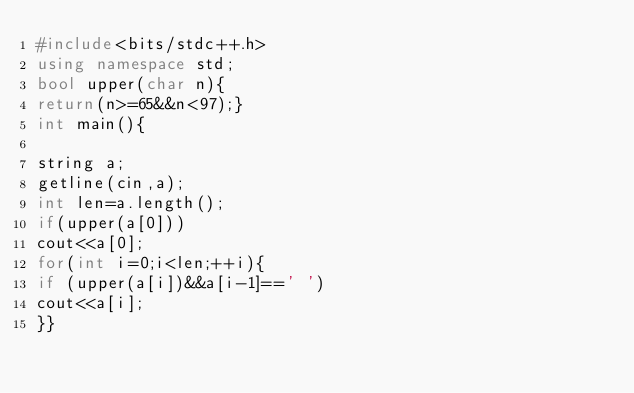<code> <loc_0><loc_0><loc_500><loc_500><_C++_>#include<bits/stdc++.h>
using namespace std;
bool upper(char n){
return(n>=65&&n<97);}
int main(){

string a;
getline(cin,a);
int len=a.length();
if(upper(a[0]))
cout<<a[0];
for(int i=0;i<len;++i){
if (upper(a[i])&&a[i-1]==' ')
cout<<a[i];
}}</code> 